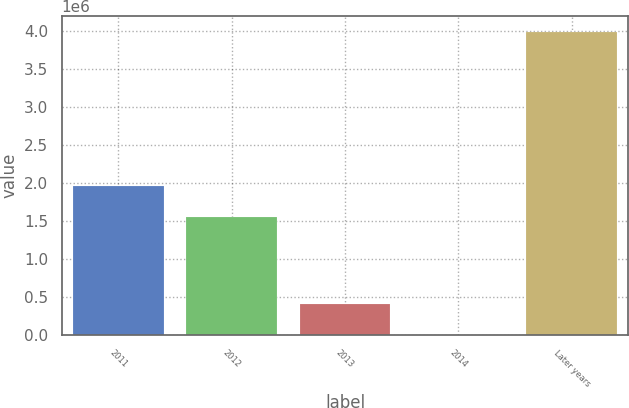Convert chart to OTSL. <chart><loc_0><loc_0><loc_500><loc_500><bar_chart><fcel>2011<fcel>2012<fcel>2013<fcel>2014<fcel>Later years<nl><fcel>1.95908e+06<fcel>1.56062e+06<fcel>406036<fcel>7570<fcel>3.99224e+06<nl></chart> 